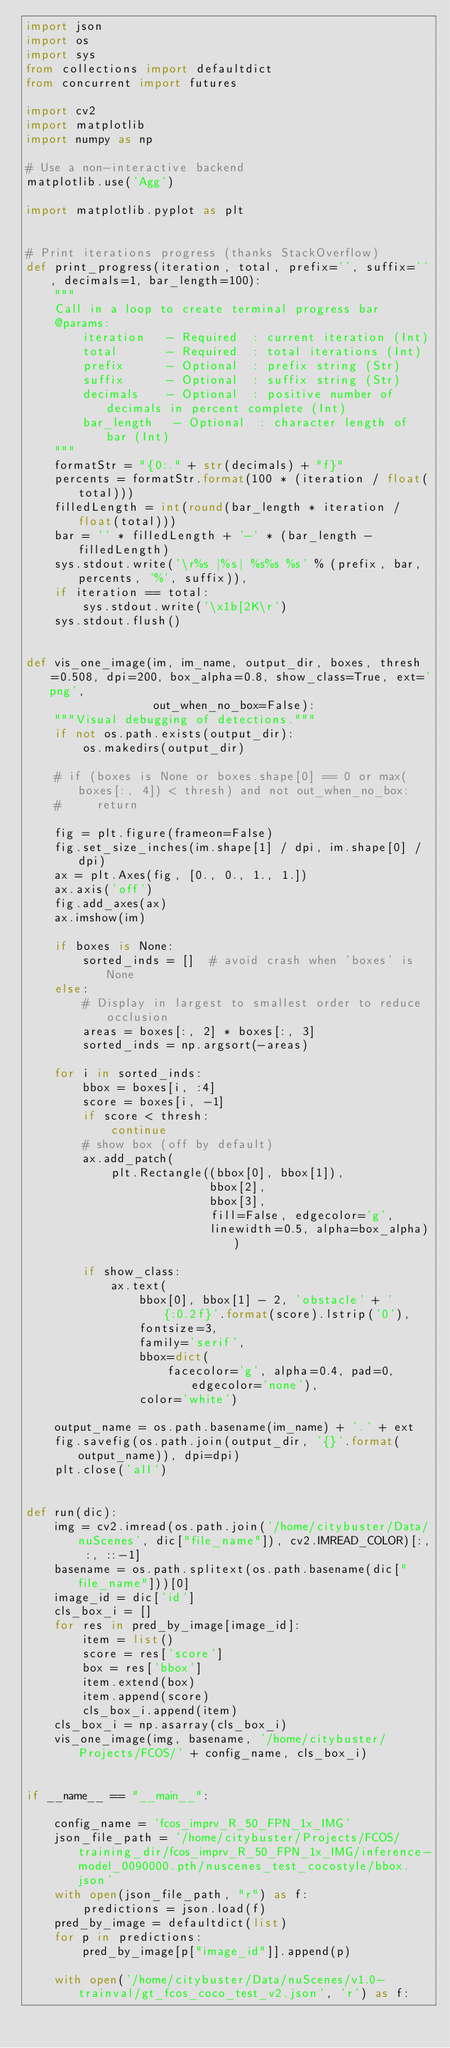<code> <loc_0><loc_0><loc_500><loc_500><_Python_>import json
import os
import sys
from collections import defaultdict
from concurrent import futures

import cv2
import matplotlib
import numpy as np

# Use a non-interactive backend
matplotlib.use('Agg')

import matplotlib.pyplot as plt


# Print iterations progress (thanks StackOverflow)
def print_progress(iteration, total, prefix='', suffix='', decimals=1, bar_length=100):
    """
    Call in a loop to create terminal progress bar
    @params:
        iteration   - Required  : current iteration (Int)
        total       - Required  : total iterations (Int)
        prefix      - Optional  : prefix string (Str)
        suffix      - Optional  : suffix string (Str)
        decimals    - Optional  : positive number of decimals in percent complete (Int)
        bar_length   - Optional  : character length of bar (Int)
    """
    formatStr = "{0:." + str(decimals) + "f}"
    percents = formatStr.format(100 * (iteration / float(total)))
    filledLength = int(round(bar_length * iteration / float(total)))
    bar = '' * filledLength + '-' * (bar_length - filledLength)
    sys.stdout.write('\r%s |%s| %s%s %s' % (prefix, bar, percents, '%', suffix)),
    if iteration == total:
        sys.stdout.write('\x1b[2K\r')
    sys.stdout.flush()


def vis_one_image(im, im_name, output_dir, boxes, thresh=0.508, dpi=200, box_alpha=0.8, show_class=True, ext='png',
                  out_when_no_box=False):
    """Visual debugging of detections."""
    if not os.path.exists(output_dir):
        os.makedirs(output_dir)

    # if (boxes is None or boxes.shape[0] == 0 or max(boxes[:, 4]) < thresh) and not out_when_no_box:
    #     return

    fig = plt.figure(frameon=False)
    fig.set_size_inches(im.shape[1] / dpi, im.shape[0] / dpi)
    ax = plt.Axes(fig, [0., 0., 1., 1.])
    ax.axis('off')
    fig.add_axes(ax)
    ax.imshow(im)

    if boxes is None:
        sorted_inds = []  # avoid crash when 'boxes' is None
    else:
        # Display in largest to smallest order to reduce occlusion
        areas = boxes[:, 2] * boxes[:, 3]
        sorted_inds = np.argsort(-areas)

    for i in sorted_inds:
        bbox = boxes[i, :4]
        score = boxes[i, -1]
        if score < thresh:
            continue
        # show box (off by default)
        ax.add_patch(
            plt.Rectangle((bbox[0], bbox[1]),
                          bbox[2],
                          bbox[3],
                          fill=False, edgecolor='g',
                          linewidth=0.5, alpha=box_alpha))

        if show_class:
            ax.text(
                bbox[0], bbox[1] - 2, 'obstacle' + ' {:0.2f}'.format(score).lstrip('0'),
                fontsize=3,
                family='serif',
                bbox=dict(
                    facecolor='g', alpha=0.4, pad=0, edgecolor='none'),
                color='white')

    output_name = os.path.basename(im_name) + '.' + ext
    fig.savefig(os.path.join(output_dir, '{}'.format(output_name)), dpi=dpi)
    plt.close('all')


def run(dic):
    img = cv2.imread(os.path.join('/home/citybuster/Data/nuScenes', dic["file_name"]), cv2.IMREAD_COLOR)[:, :, ::-1]
    basename = os.path.splitext(os.path.basename(dic["file_name"]))[0]
    image_id = dic['id']
    cls_box_i = []
    for res in pred_by_image[image_id]:
        item = list()
        score = res['score']
        box = res['bbox']
        item.extend(box)
        item.append(score)
        cls_box_i.append(item)
    cls_box_i = np.asarray(cls_box_i)
    vis_one_image(img, basename, '/home/citybuster/Projects/FCOS/' + config_name, cls_box_i)


if __name__ == "__main__":

    config_name = 'fcos_imprv_R_50_FPN_1x_IMG'
    json_file_path = '/home/citybuster/Projects/FCOS/training_dir/fcos_imprv_R_50_FPN_1x_IMG/inference-model_0090000.pth/nuscenes_test_cocostyle/bbox.json'
    with open(json_file_path, "r") as f:
        predictions = json.load(f)
    pred_by_image = defaultdict(list)
    for p in predictions:
        pred_by_image[p["image_id"]].append(p)

    with open('/home/citybuster/Data/nuScenes/v1.0-trainval/gt_fcos_coco_test_v2.json', 'r') as f:</code> 